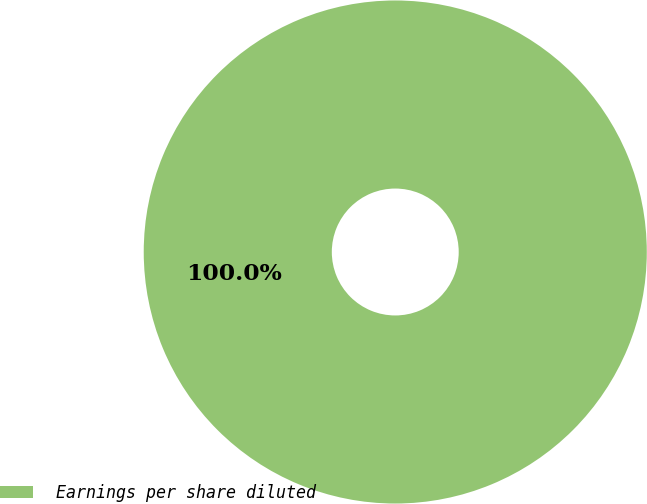<chart> <loc_0><loc_0><loc_500><loc_500><pie_chart><fcel>Earnings per share diluted<nl><fcel>100.0%<nl></chart> 